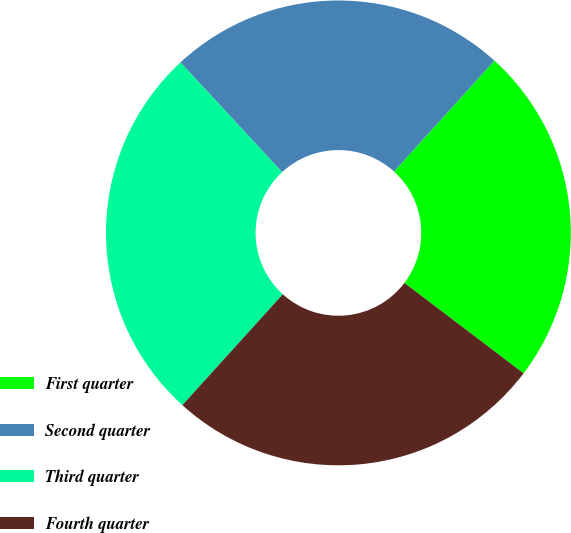Convert chart to OTSL. <chart><loc_0><loc_0><loc_500><loc_500><pie_chart><fcel>First quarter<fcel>Second quarter<fcel>Third quarter<fcel>Fourth quarter<nl><fcel>23.61%<fcel>23.61%<fcel>26.39%<fcel>26.39%<nl></chart> 